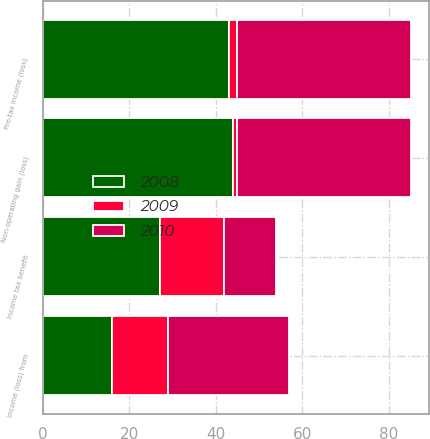Convert chart. <chart><loc_0><loc_0><loc_500><loc_500><stacked_bar_chart><ecel><fcel>Non-operating gain (loss)<fcel>Pre-tax income (loss)<fcel>Income tax benefit<fcel>Income (loss) from<nl><fcel>2010<fcel>40<fcel>40<fcel>12<fcel>28<nl><fcel>2008<fcel>44<fcel>43<fcel>27<fcel>16<nl><fcel>2009<fcel>1<fcel>2<fcel>15<fcel>13<nl></chart> 